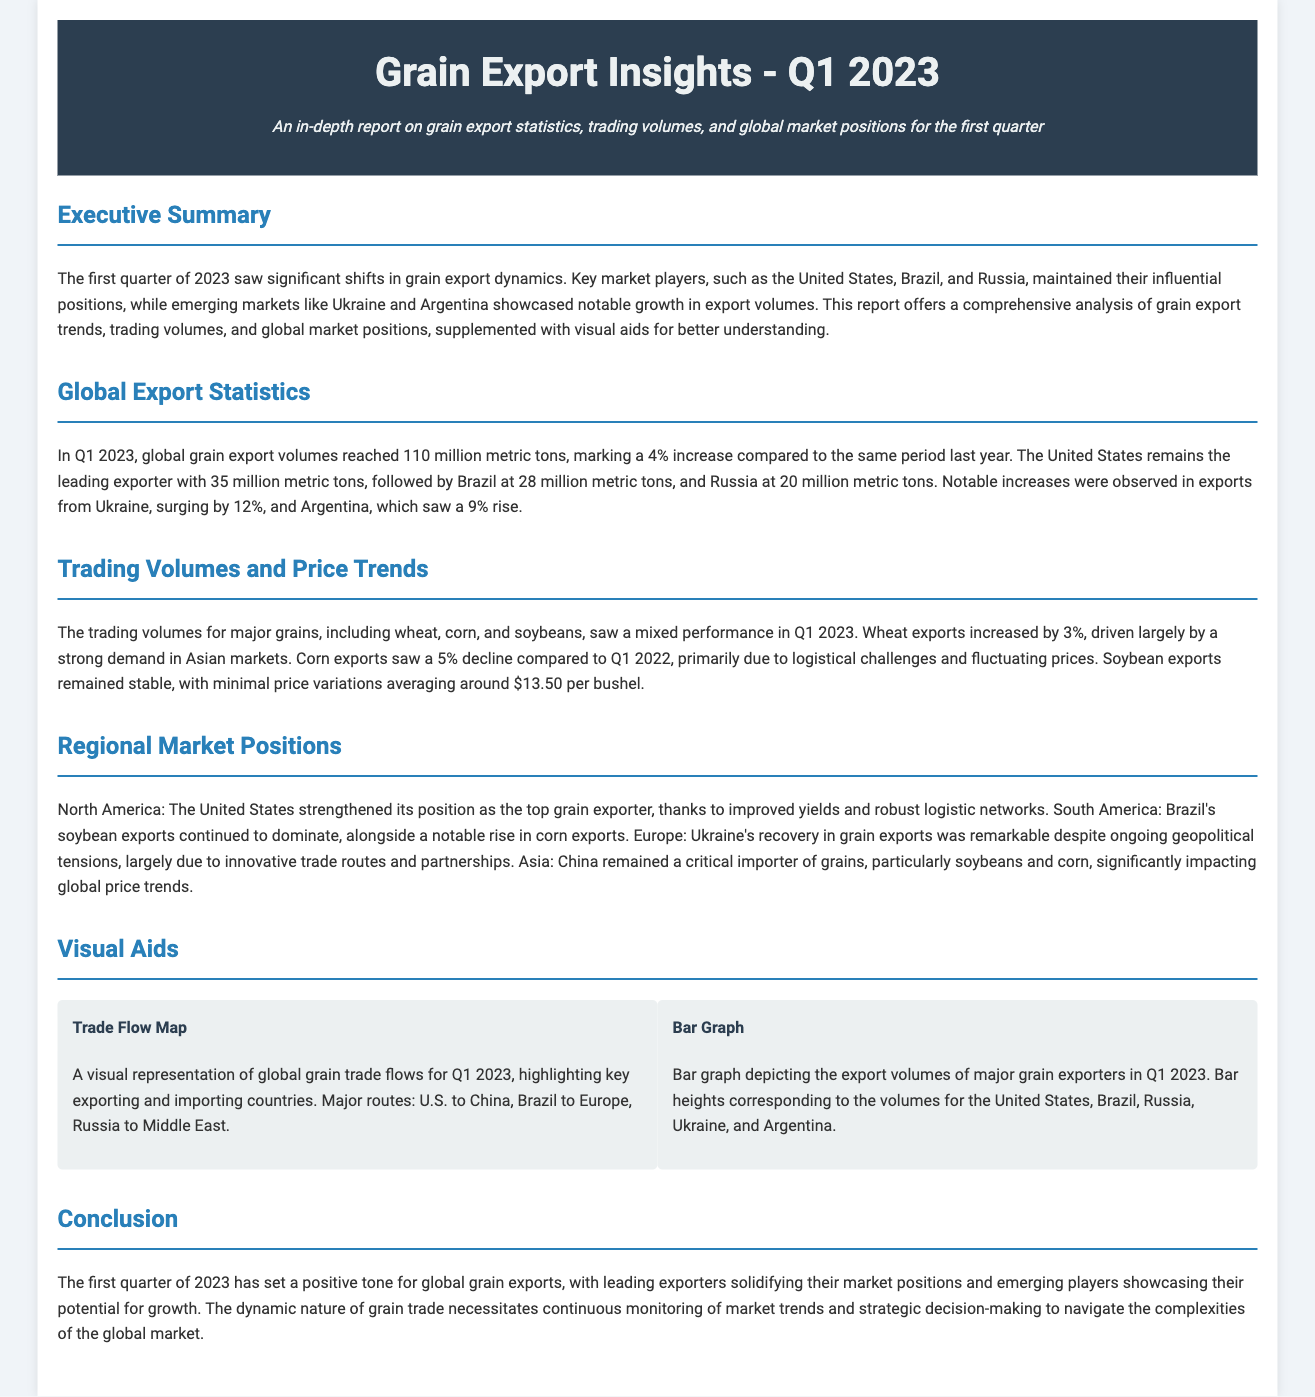What was the total global grain export volume in Q1 2023? The document states that global grain export volumes reached 110 million metric tons in Q1 2023.
Answer: 110 million metric tons Who remained the leading exporter in Q1 2023? The report mentions that the United States remains the leading exporter with 35 million metric tons.
Answer: United States By what percentage did Ukraine's exports increase? The document indicates that exports from Ukraine surged by 12% in Q1 2023.
Answer: 12% What trend did wheat exports show in Q1 2023? The document notes that wheat exports increased by 3% driven by strong demand.
Answer: Increased Which country saw a notable rise in soybean exports in South America? Brazil's soybean exports continued to dominate, as mentioned in the regional market positions section.
Answer: Brazil What visual aid displays the export volumes of major grain exporters? The report includes a bar graph depicting the export volumes of major grain exporters in Q1 2023.
Answer: Bar Graph 